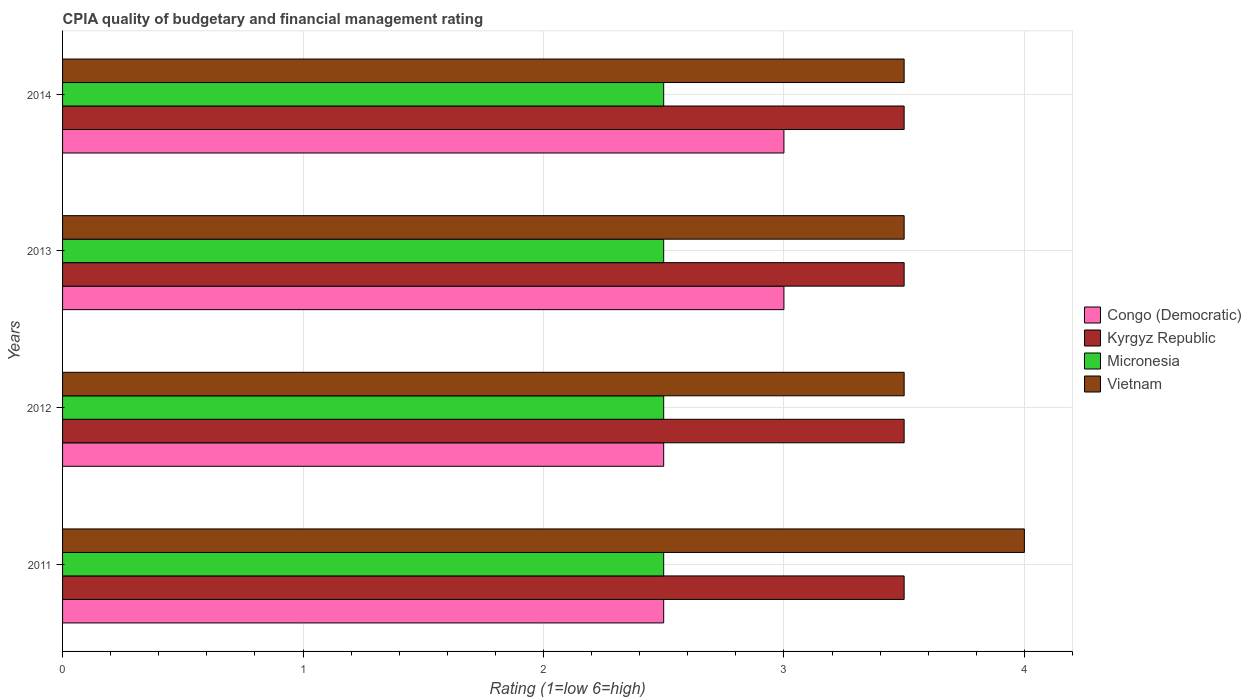How many different coloured bars are there?
Keep it short and to the point. 4. How many bars are there on the 1st tick from the top?
Your response must be concise. 4. How many bars are there on the 2nd tick from the bottom?
Offer a very short reply. 4. In how many cases, is the number of bars for a given year not equal to the number of legend labels?
Make the answer very short. 0. Across all years, what is the maximum CPIA rating in Congo (Democratic)?
Make the answer very short. 3. Across all years, what is the minimum CPIA rating in Vietnam?
Your answer should be compact. 3.5. What is the difference between the CPIA rating in Congo (Democratic) in 2014 and the CPIA rating in Micronesia in 2012?
Provide a short and direct response. 0.5. What is the average CPIA rating in Vietnam per year?
Provide a short and direct response. 3.62. In the year 2014, what is the difference between the CPIA rating in Kyrgyz Republic and CPIA rating in Congo (Democratic)?
Your response must be concise. 0.5. In how many years, is the CPIA rating in Vietnam greater than 1 ?
Keep it short and to the point. 4. What is the ratio of the CPIA rating in Congo (Democratic) in 2011 to that in 2014?
Your response must be concise. 0.83. Is the CPIA rating in Congo (Democratic) in 2012 less than that in 2014?
Keep it short and to the point. Yes. Is the difference between the CPIA rating in Kyrgyz Republic in 2012 and 2014 greater than the difference between the CPIA rating in Congo (Democratic) in 2012 and 2014?
Keep it short and to the point. Yes. What is the difference between the highest and the second highest CPIA rating in Kyrgyz Republic?
Provide a short and direct response. 0. What is the difference between the highest and the lowest CPIA rating in Kyrgyz Republic?
Keep it short and to the point. 0. What does the 4th bar from the top in 2011 represents?
Provide a succinct answer. Congo (Democratic). What does the 1st bar from the bottom in 2014 represents?
Offer a very short reply. Congo (Democratic). How many bars are there?
Your answer should be compact. 16. Does the graph contain any zero values?
Ensure brevity in your answer.  No. Where does the legend appear in the graph?
Provide a short and direct response. Center right. How many legend labels are there?
Provide a succinct answer. 4. What is the title of the graph?
Offer a very short reply. CPIA quality of budgetary and financial management rating. What is the label or title of the X-axis?
Provide a short and direct response. Rating (1=low 6=high). What is the Rating (1=low 6=high) of Kyrgyz Republic in 2011?
Your answer should be very brief. 3.5. What is the Rating (1=low 6=high) of Micronesia in 2011?
Offer a terse response. 2.5. What is the Rating (1=low 6=high) of Congo (Democratic) in 2013?
Ensure brevity in your answer.  3. What is the Rating (1=low 6=high) in Kyrgyz Republic in 2013?
Offer a terse response. 3.5. What is the Rating (1=low 6=high) of Vietnam in 2013?
Provide a short and direct response. 3.5. What is the Rating (1=low 6=high) in Kyrgyz Republic in 2014?
Your response must be concise. 3.5. What is the Rating (1=low 6=high) in Vietnam in 2014?
Ensure brevity in your answer.  3.5. Across all years, what is the maximum Rating (1=low 6=high) in Kyrgyz Republic?
Ensure brevity in your answer.  3.5. Across all years, what is the maximum Rating (1=low 6=high) in Vietnam?
Provide a succinct answer. 4. Across all years, what is the minimum Rating (1=low 6=high) of Kyrgyz Republic?
Offer a terse response. 3.5. What is the total Rating (1=low 6=high) in Congo (Democratic) in the graph?
Provide a succinct answer. 11. What is the total Rating (1=low 6=high) in Micronesia in the graph?
Ensure brevity in your answer.  10. What is the difference between the Rating (1=low 6=high) of Congo (Democratic) in 2011 and that in 2012?
Keep it short and to the point. 0. What is the difference between the Rating (1=low 6=high) in Micronesia in 2011 and that in 2012?
Ensure brevity in your answer.  0. What is the difference between the Rating (1=low 6=high) in Vietnam in 2011 and that in 2012?
Your response must be concise. 0.5. What is the difference between the Rating (1=low 6=high) of Congo (Democratic) in 2011 and that in 2013?
Ensure brevity in your answer.  -0.5. What is the difference between the Rating (1=low 6=high) of Micronesia in 2011 and that in 2013?
Make the answer very short. 0. What is the difference between the Rating (1=low 6=high) of Vietnam in 2011 and that in 2013?
Provide a short and direct response. 0.5. What is the difference between the Rating (1=low 6=high) of Micronesia in 2011 and that in 2014?
Offer a very short reply. 0. What is the difference between the Rating (1=low 6=high) of Vietnam in 2012 and that in 2013?
Provide a succinct answer. 0. What is the difference between the Rating (1=low 6=high) in Congo (Democratic) in 2012 and that in 2014?
Your answer should be very brief. -0.5. What is the difference between the Rating (1=low 6=high) of Kyrgyz Republic in 2012 and that in 2014?
Keep it short and to the point. 0. What is the difference between the Rating (1=low 6=high) in Vietnam in 2012 and that in 2014?
Your answer should be very brief. 0. What is the difference between the Rating (1=low 6=high) in Kyrgyz Republic in 2013 and that in 2014?
Ensure brevity in your answer.  0. What is the difference between the Rating (1=low 6=high) in Micronesia in 2013 and that in 2014?
Make the answer very short. 0. What is the difference between the Rating (1=low 6=high) in Micronesia in 2011 and the Rating (1=low 6=high) in Vietnam in 2012?
Offer a terse response. -1. What is the difference between the Rating (1=low 6=high) of Congo (Democratic) in 2011 and the Rating (1=low 6=high) of Kyrgyz Republic in 2013?
Your answer should be compact. -1. What is the difference between the Rating (1=low 6=high) in Congo (Democratic) in 2011 and the Rating (1=low 6=high) in Vietnam in 2013?
Provide a succinct answer. -1. What is the difference between the Rating (1=low 6=high) of Kyrgyz Republic in 2011 and the Rating (1=low 6=high) of Vietnam in 2013?
Keep it short and to the point. 0. What is the difference between the Rating (1=low 6=high) of Kyrgyz Republic in 2011 and the Rating (1=low 6=high) of Vietnam in 2014?
Ensure brevity in your answer.  0. What is the difference between the Rating (1=low 6=high) of Congo (Democratic) in 2012 and the Rating (1=low 6=high) of Kyrgyz Republic in 2013?
Offer a terse response. -1. What is the difference between the Rating (1=low 6=high) in Kyrgyz Republic in 2012 and the Rating (1=low 6=high) in Micronesia in 2013?
Give a very brief answer. 1. What is the difference between the Rating (1=low 6=high) of Kyrgyz Republic in 2012 and the Rating (1=low 6=high) of Vietnam in 2013?
Your answer should be compact. 0. What is the difference between the Rating (1=low 6=high) of Congo (Democratic) in 2012 and the Rating (1=low 6=high) of Kyrgyz Republic in 2014?
Your response must be concise. -1. What is the difference between the Rating (1=low 6=high) in Micronesia in 2012 and the Rating (1=low 6=high) in Vietnam in 2014?
Keep it short and to the point. -1. What is the difference between the Rating (1=low 6=high) in Congo (Democratic) in 2013 and the Rating (1=low 6=high) in Kyrgyz Republic in 2014?
Make the answer very short. -0.5. What is the difference between the Rating (1=low 6=high) in Congo (Democratic) in 2013 and the Rating (1=low 6=high) in Vietnam in 2014?
Offer a terse response. -0.5. What is the average Rating (1=low 6=high) in Congo (Democratic) per year?
Ensure brevity in your answer.  2.75. What is the average Rating (1=low 6=high) of Kyrgyz Republic per year?
Your answer should be compact. 3.5. What is the average Rating (1=low 6=high) of Micronesia per year?
Offer a very short reply. 2.5. What is the average Rating (1=low 6=high) in Vietnam per year?
Provide a short and direct response. 3.62. In the year 2011, what is the difference between the Rating (1=low 6=high) in Congo (Democratic) and Rating (1=low 6=high) in Kyrgyz Republic?
Your response must be concise. -1. In the year 2011, what is the difference between the Rating (1=low 6=high) in Congo (Democratic) and Rating (1=low 6=high) in Micronesia?
Your answer should be very brief. 0. In the year 2011, what is the difference between the Rating (1=low 6=high) of Kyrgyz Republic and Rating (1=low 6=high) of Micronesia?
Your answer should be very brief. 1. In the year 2011, what is the difference between the Rating (1=low 6=high) in Kyrgyz Republic and Rating (1=low 6=high) in Vietnam?
Offer a terse response. -0.5. In the year 2012, what is the difference between the Rating (1=low 6=high) of Congo (Democratic) and Rating (1=low 6=high) of Vietnam?
Offer a terse response. -1. In the year 2013, what is the difference between the Rating (1=low 6=high) in Congo (Democratic) and Rating (1=low 6=high) in Kyrgyz Republic?
Keep it short and to the point. -0.5. In the year 2013, what is the difference between the Rating (1=low 6=high) in Congo (Democratic) and Rating (1=low 6=high) in Micronesia?
Provide a succinct answer. 0.5. In the year 2013, what is the difference between the Rating (1=low 6=high) in Congo (Democratic) and Rating (1=low 6=high) in Vietnam?
Ensure brevity in your answer.  -0.5. In the year 2014, what is the difference between the Rating (1=low 6=high) in Congo (Democratic) and Rating (1=low 6=high) in Vietnam?
Keep it short and to the point. -0.5. In the year 2014, what is the difference between the Rating (1=low 6=high) in Micronesia and Rating (1=low 6=high) in Vietnam?
Provide a short and direct response. -1. What is the ratio of the Rating (1=low 6=high) of Congo (Democratic) in 2011 to that in 2012?
Your response must be concise. 1. What is the ratio of the Rating (1=low 6=high) of Micronesia in 2011 to that in 2012?
Your answer should be very brief. 1. What is the ratio of the Rating (1=low 6=high) in Vietnam in 2011 to that in 2012?
Provide a short and direct response. 1.14. What is the ratio of the Rating (1=low 6=high) in Congo (Democratic) in 2011 to that in 2013?
Give a very brief answer. 0.83. What is the ratio of the Rating (1=low 6=high) in Congo (Democratic) in 2011 to that in 2014?
Offer a terse response. 0.83. What is the ratio of the Rating (1=low 6=high) of Kyrgyz Republic in 2011 to that in 2014?
Provide a succinct answer. 1. What is the ratio of the Rating (1=low 6=high) in Vietnam in 2011 to that in 2014?
Offer a terse response. 1.14. What is the ratio of the Rating (1=low 6=high) in Kyrgyz Republic in 2012 to that in 2013?
Your response must be concise. 1. What is the ratio of the Rating (1=low 6=high) in Micronesia in 2012 to that in 2013?
Provide a short and direct response. 1. What is the ratio of the Rating (1=low 6=high) in Congo (Democratic) in 2012 to that in 2014?
Offer a terse response. 0.83. What is the ratio of the Rating (1=low 6=high) of Kyrgyz Republic in 2012 to that in 2014?
Keep it short and to the point. 1. What is the ratio of the Rating (1=low 6=high) in Vietnam in 2012 to that in 2014?
Your answer should be very brief. 1. What is the ratio of the Rating (1=low 6=high) of Congo (Democratic) in 2013 to that in 2014?
Offer a terse response. 1. What is the difference between the highest and the second highest Rating (1=low 6=high) of Congo (Democratic)?
Make the answer very short. 0. What is the difference between the highest and the second highest Rating (1=low 6=high) of Kyrgyz Republic?
Provide a short and direct response. 0. What is the difference between the highest and the second highest Rating (1=low 6=high) in Micronesia?
Make the answer very short. 0. What is the difference between the highest and the lowest Rating (1=low 6=high) in Congo (Democratic)?
Ensure brevity in your answer.  0.5. What is the difference between the highest and the lowest Rating (1=low 6=high) in Kyrgyz Republic?
Offer a terse response. 0. What is the difference between the highest and the lowest Rating (1=low 6=high) of Micronesia?
Provide a short and direct response. 0. 